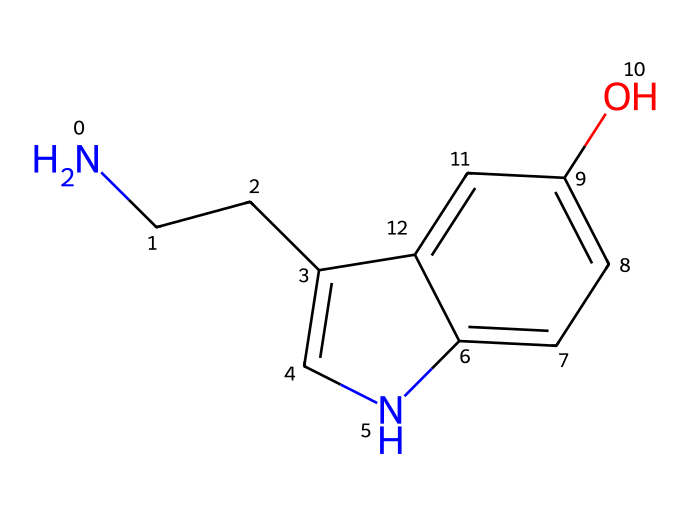What is the molecular formula of serotonin? To determine the molecular formula from the SMILES representation, we identify the number of each type of atom present. The SMILES notation includes carbon (C), hydrogen (H), oxygen (O), and nitrogen (N). By counting, we find there are 10 carbons, 12 hydrogens, 1 nitrogen, and 1 oxygen, resulting in the molecular formula C10H12N2O.
Answer: C10H12N2O How many nitrogen atoms are present in serotonin? By examining the SMILES structure, we can see that there is one nitrogen atom denoted by the letter "N". Thus, the answer is straightforward.
Answer: 1 What functional group is indicated by the presence of the -OH group in serotonin? The -OH group indicates the presence of a hydroxyl functional group, contributing to the structure's classification as a phenolic compound. The position of this group is also crucial for understanding its biological activity.
Answer: hydroxyl What type of receptor does serotonin primarily bind to? Serotonin primarily binds to serotonin receptors, which belong to the family of G-protein coupled receptors and are involved in various physiological processes.
Answer: serotonin receptors How does the structure of serotonin contribute to its classification as a neurotransmitter? The structure includes a biogenic amine (the amine group from the nitrogen), which is characteristic of neurotransmitters. The presence of the cyclic structure and the nitrogen atom indicates its role in neuron communication, linking it to mood and behavior regulation.
Answer: neurotransmitter Does serotonin contain any aromatic rings? Yes, the SMILES notation indicates there are aromatic rings present in the structure; specifically, the "c" letters in the representation denote aromatic carbon atoms.
Answer: yes What is the primary role of serotonin in the human body? Serotonin is best known for its role in regulating mood, contributing to feelings of well-being and happiness, which is why it is often called the "happiness hormone”.
Answer: mood regulation 